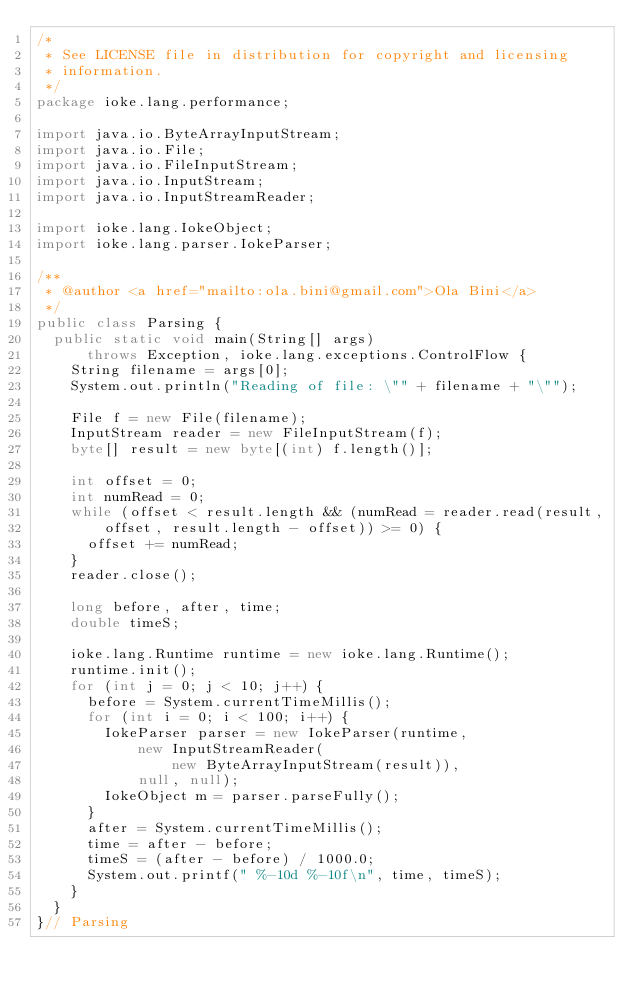Convert code to text. <code><loc_0><loc_0><loc_500><loc_500><_Java_>/*
 * See LICENSE file in distribution for copyright and licensing
 * information.
 */
package ioke.lang.performance;

import java.io.ByteArrayInputStream;
import java.io.File;
import java.io.FileInputStream;
import java.io.InputStream;
import java.io.InputStreamReader;

import ioke.lang.IokeObject;
import ioke.lang.parser.IokeParser;

/**
 * @author <a href="mailto:ola.bini@gmail.com">Ola Bini</a>
 */
public class Parsing {
	public static void main(String[] args)
			throws Exception, ioke.lang.exceptions.ControlFlow {
		String filename = args[0];
		System.out.println("Reading of file: \"" + filename + "\"");

		File f = new File(filename);
		InputStream reader = new FileInputStream(f);
		byte[] result = new byte[(int) f.length()];

		int offset = 0;
		int numRead = 0;
		while (offset < result.length && (numRead = reader.read(result,
				offset, result.length - offset)) >= 0) {
			offset += numRead;
		}
		reader.close();

		long before, after, time;
		double timeS;

		ioke.lang.Runtime runtime = new ioke.lang.Runtime();
		runtime.init();
		for (int j = 0; j < 10; j++) {
			before = System.currentTimeMillis();
			for (int i = 0; i < 100; i++) {
				IokeParser parser = new IokeParser(runtime,
						new InputStreamReader(
								new ByteArrayInputStream(result)),
						null, null);
				IokeObject m = parser.parseFully();
			}
			after = System.currentTimeMillis();
			time = after - before;
			timeS = (after - before) / 1000.0;
			System.out.printf(" %-10d %-10f\n", time, timeS);
		}
	}
}// Parsing
</code> 